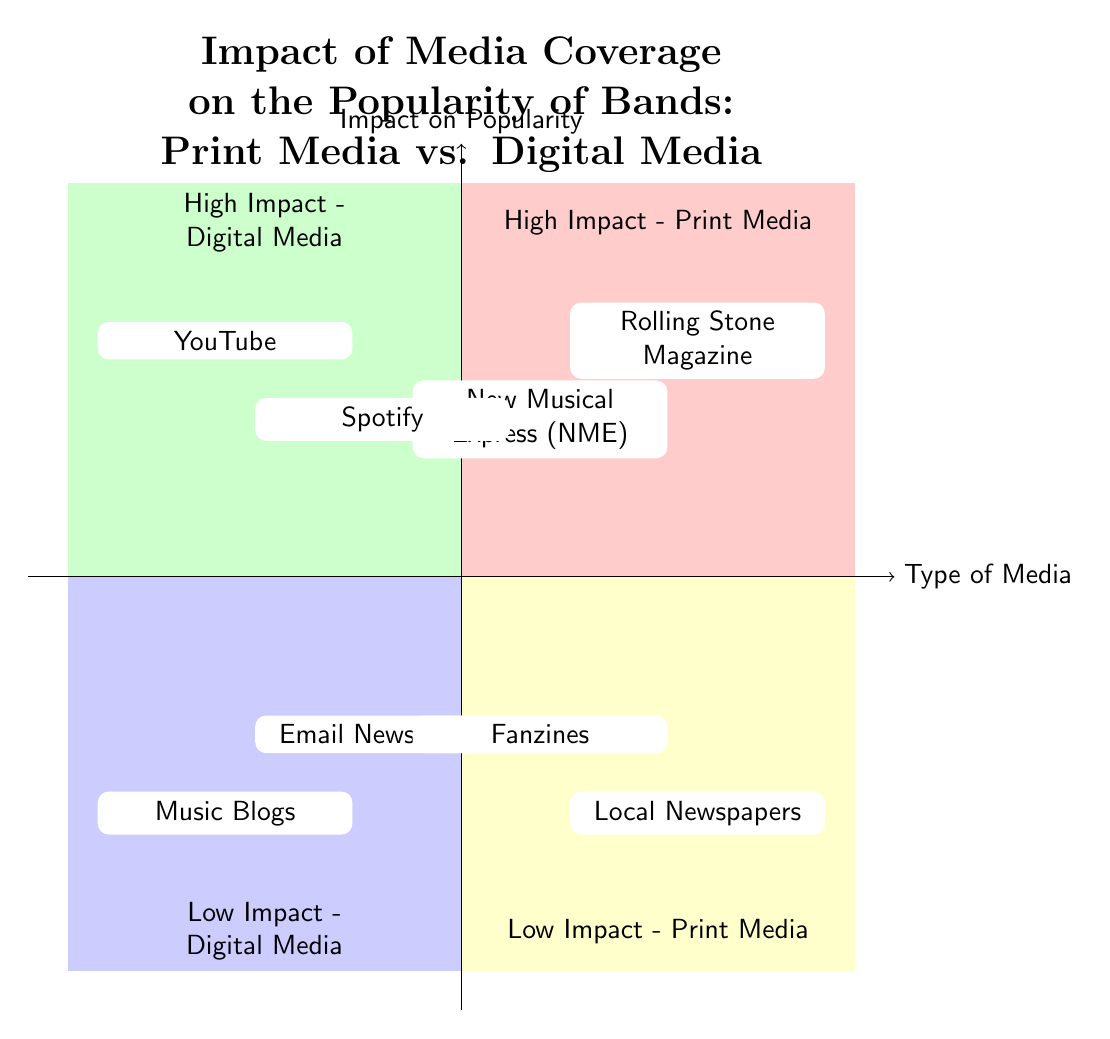What are the two elements in the "High Impact - Print Media" quadrant? The two elements in the "High Impact - Print Media" quadrant are listed in the diagram as "Rolling Stone Magazine" and "New Musical Express (NME)."
Answer: Rolling Stone Magazine, New Musical Express (NME) Which quadrant contains "YouTube"? "YouTube" is located in the "High Impact - Digital Media" quadrant, as indicated by its position in the diagram.
Answer: High Impact - Digital Media How many elements are in the "Low Impact - Print Media" quadrant? The "Low Impact - Print Media" quadrant contains two elements: "Local Newspapers" and "Fanzines," as noted in the diagram.
Answer: 2 What is the main difference between the "High Impact" and "Low Impact" quadrants for digital media? The distinction is based on how significantly media influences band popularity; in "High Impact - Digital Media," platforms like "YouTube" and "Spotify" are mentioned, while "Low Impact - Digital Media" includes "Music Blogs" and "Email Newsletters," which have minimal influence.
Answer: Type of influence List the two platforms categorized under "Low Impact - Digital Media." The platforms categorized under "Low Impact - Digital Media" are "Music Blogs" and "Email Newsletters," as clearly printed in the quadrant.
Answer: Music Blogs, Email Newsletters Which print media element is described as having a limited reach? The description states that "Local Newspapers" typically have a limited reach and impact, making it clear in the diagram's text.
Answer: Local Newspapers What is the common feature of both "Rolling Stone Magazine" and "NME"? Both "Rolling Stone Magazine" and "NME" significantly enhanced band popularity through extensive coverage, which is a common feature mentioned in the descriptions.
Answer: Extensive coverage What does the "Impact on Popularity" axis measure? The "Impact on Popularity" axis measures how significantly each type of media influences the popularity of bands, ranging from low to high as per the diagram's design.
Answer: Influence level How does "Spotify" influence newer bands according to the diagram? "Spotify" is mentioned to significantly influence how newer bands gain popularity, which indicates its role as a discovery platform in the high impact quadrant.
Answer: Music discovery tool How many quadrants are present in this diagram? The diagram shows four quadrants: "High Impact - Print Media," "High Impact - Digital Media," "Low Impact - Print Media," and "Low Impact - Digital Media."
Answer: 4 